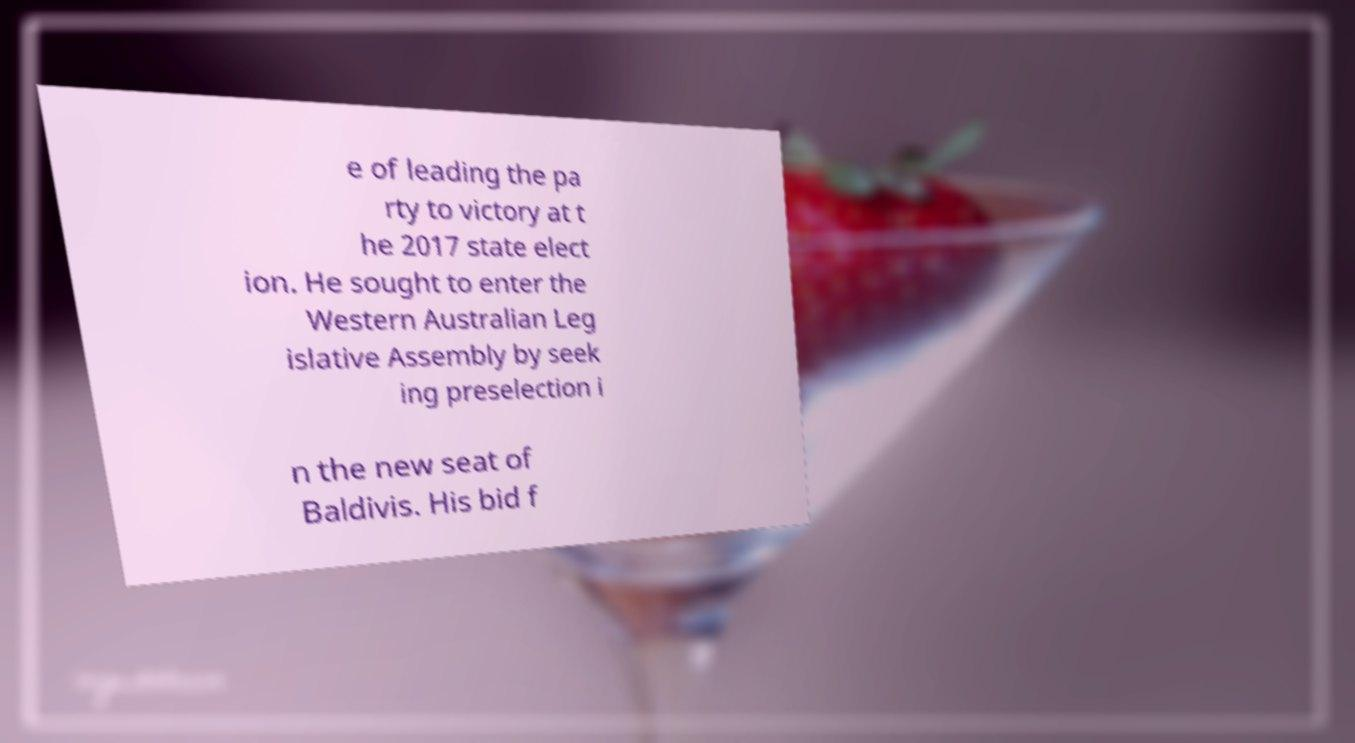Can you accurately transcribe the text from the provided image for me? e of leading the pa rty to victory at t he 2017 state elect ion. He sought to enter the Western Australian Leg islative Assembly by seek ing preselection i n the new seat of Baldivis. His bid f 